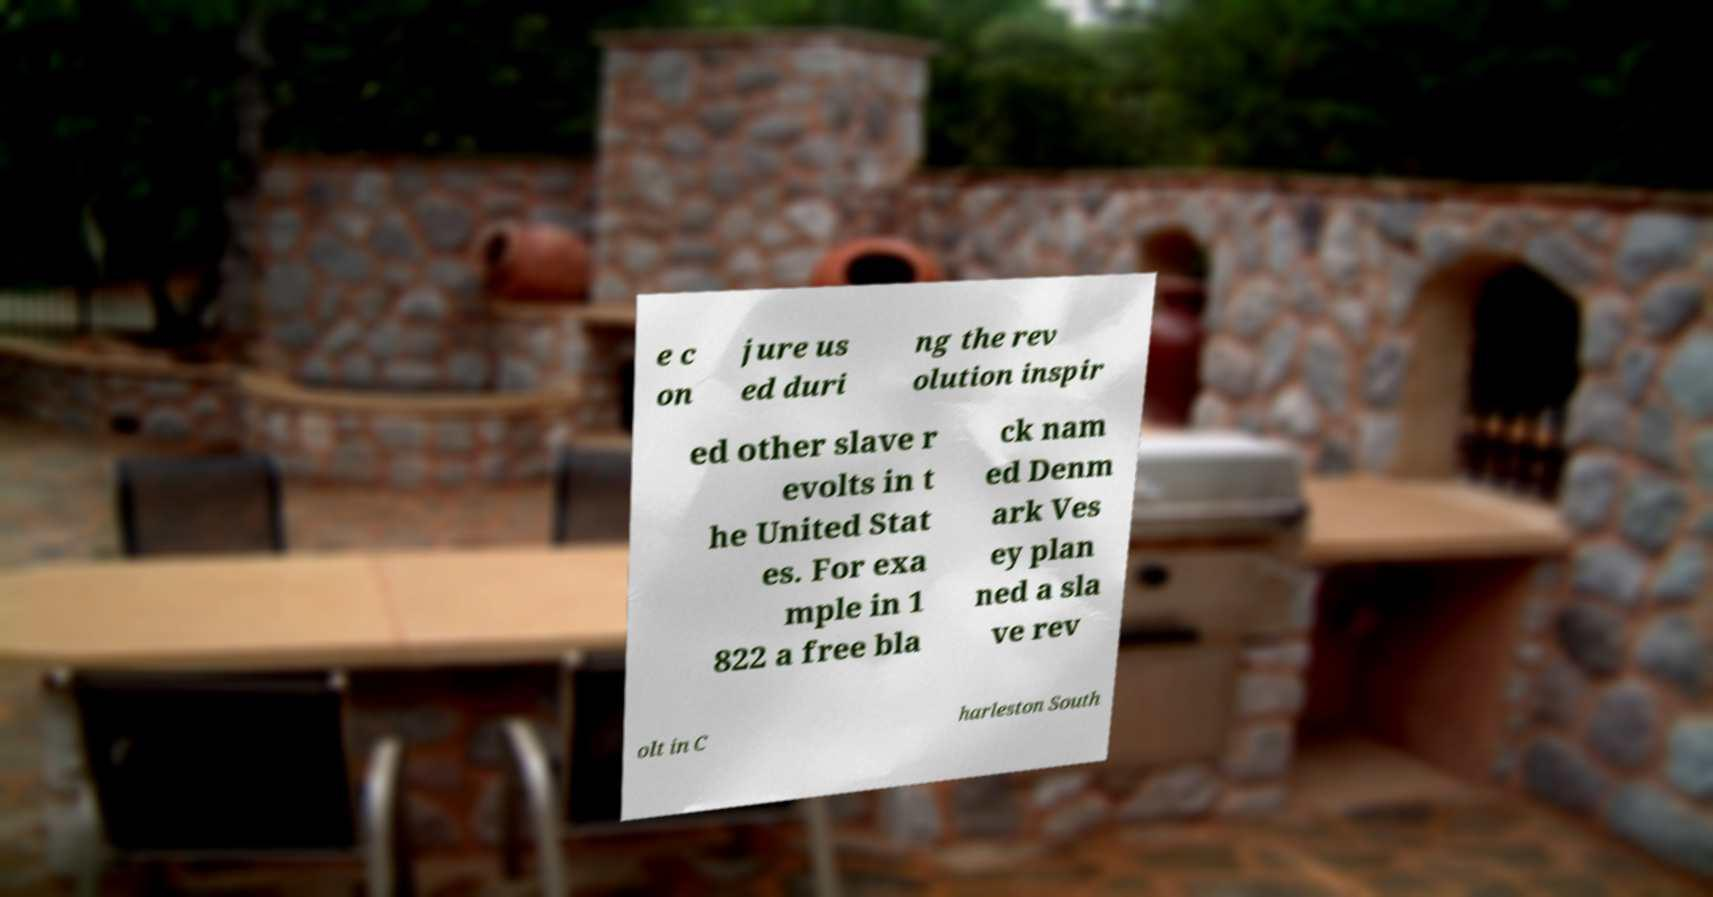What messages or text are displayed in this image? I need them in a readable, typed format. e c on jure us ed duri ng the rev olution inspir ed other slave r evolts in t he United Stat es. For exa mple in 1 822 a free bla ck nam ed Denm ark Ves ey plan ned a sla ve rev olt in C harleston South 